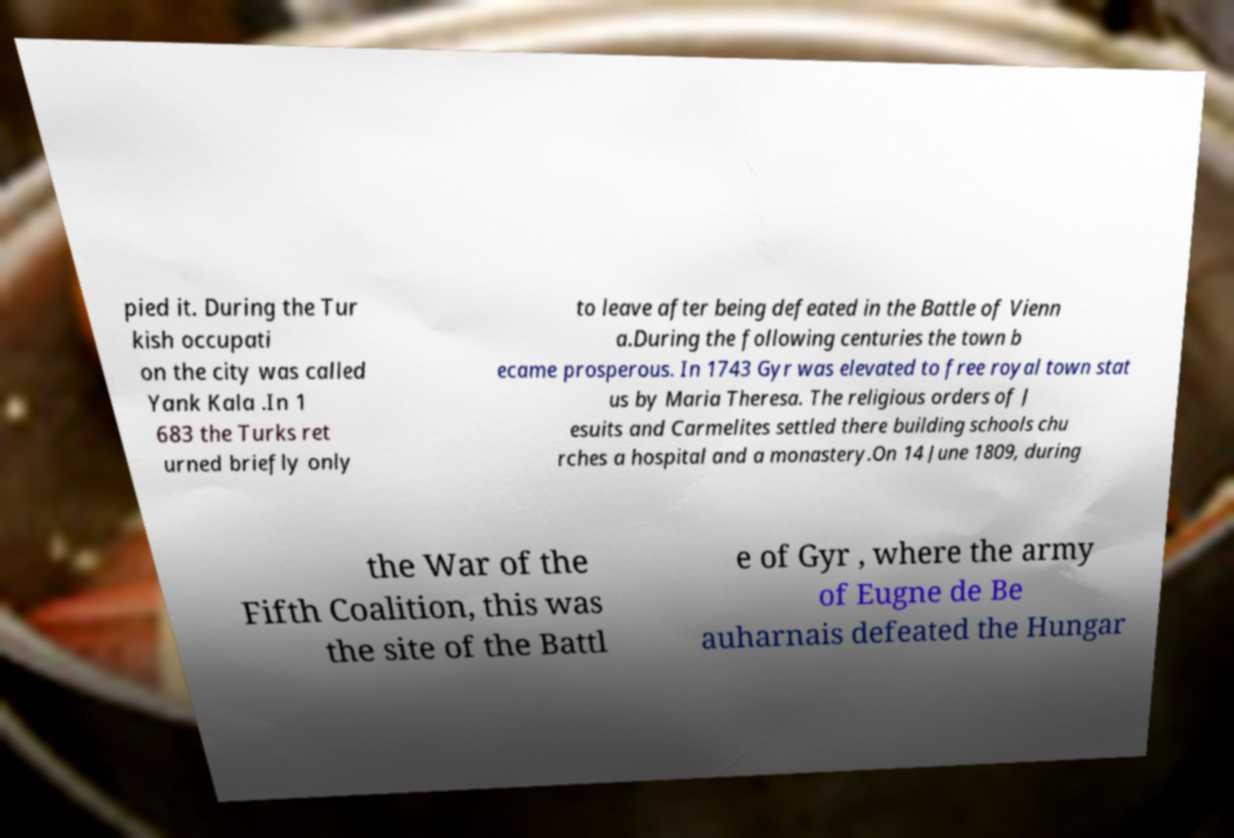For documentation purposes, I need the text within this image transcribed. Could you provide that? pied it. During the Tur kish occupati on the city was called Yank Kala .In 1 683 the Turks ret urned briefly only to leave after being defeated in the Battle of Vienn a.During the following centuries the town b ecame prosperous. In 1743 Gyr was elevated to free royal town stat us by Maria Theresa. The religious orders of J esuits and Carmelites settled there building schools chu rches a hospital and a monastery.On 14 June 1809, during the War of the Fifth Coalition, this was the site of the Battl e of Gyr , where the army of Eugne de Be auharnais defeated the Hungar 